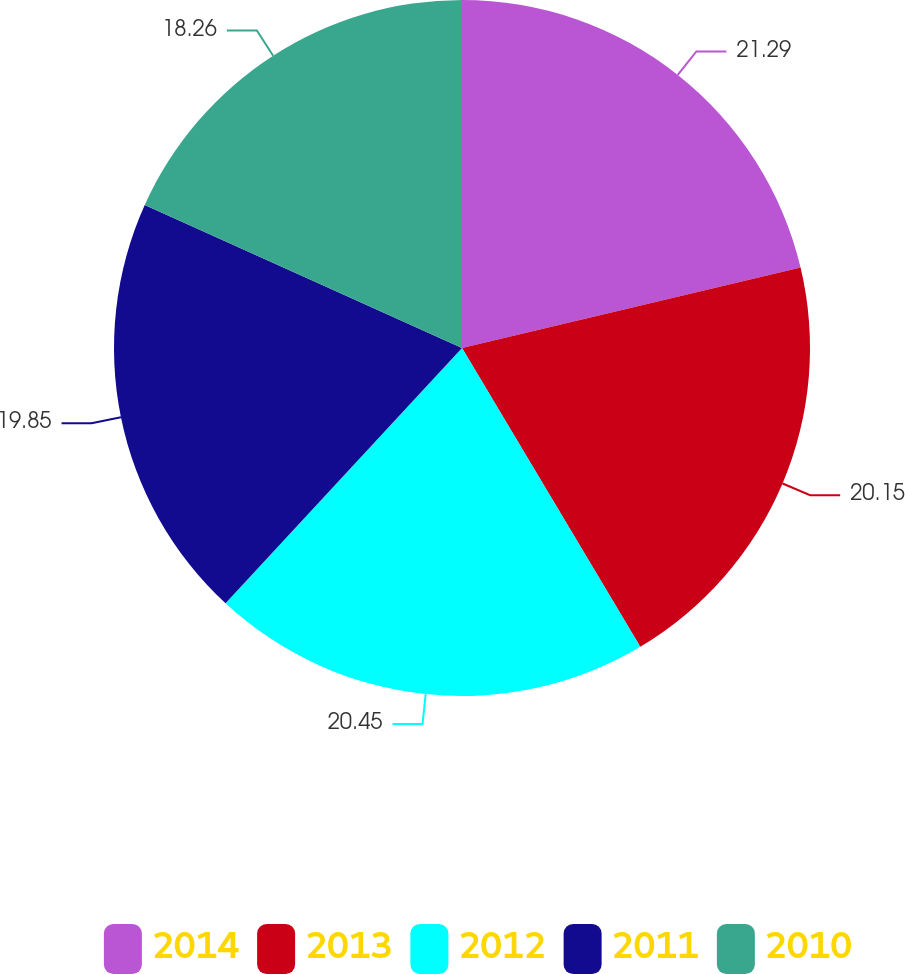<chart> <loc_0><loc_0><loc_500><loc_500><pie_chart><fcel>2014<fcel>2013<fcel>2012<fcel>2011<fcel>2010<nl><fcel>21.29%<fcel>20.15%<fcel>20.45%<fcel>19.85%<fcel>18.26%<nl></chart> 